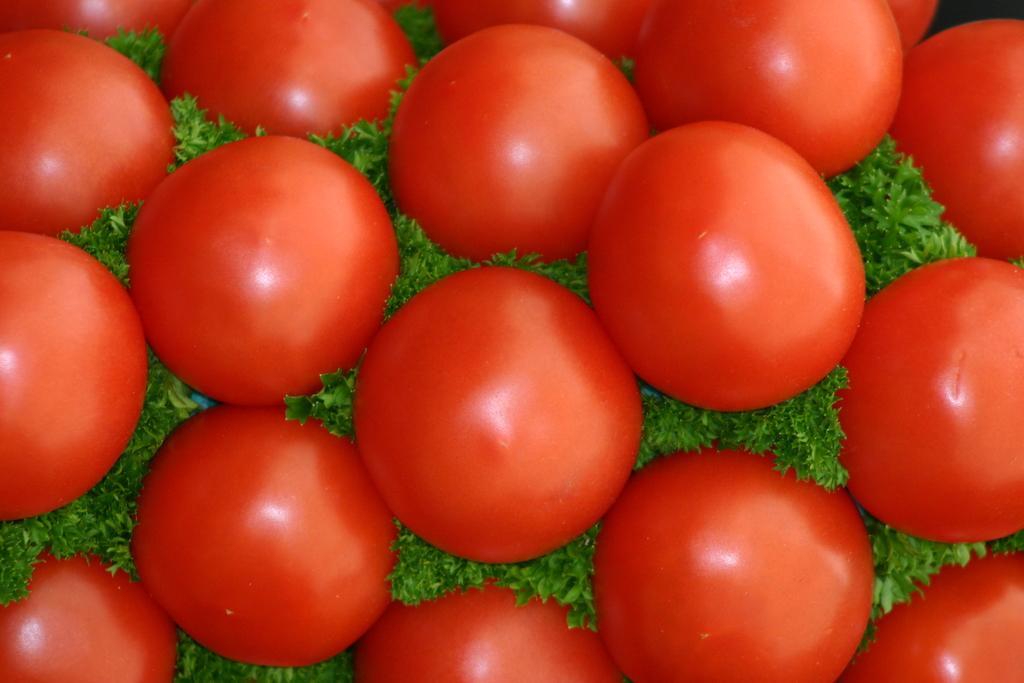Describe this image in one or two sentences. The picture consists of tomatoes and leaves. 